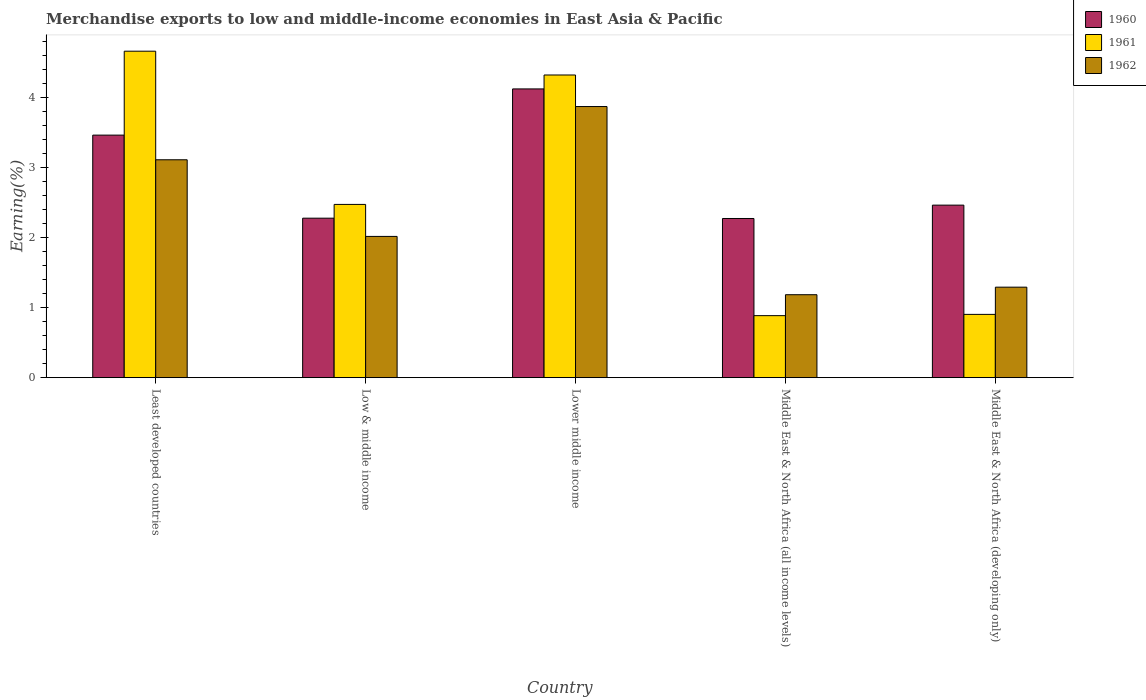How many groups of bars are there?
Your response must be concise. 5. Are the number of bars per tick equal to the number of legend labels?
Offer a terse response. Yes. How many bars are there on the 5th tick from the left?
Provide a short and direct response. 3. What is the label of the 2nd group of bars from the left?
Provide a short and direct response. Low & middle income. In how many cases, is the number of bars for a given country not equal to the number of legend labels?
Provide a succinct answer. 0. What is the percentage of amount earned from merchandise exports in 1962 in Middle East & North Africa (developing only)?
Offer a terse response. 1.29. Across all countries, what is the maximum percentage of amount earned from merchandise exports in 1961?
Provide a short and direct response. 4.66. Across all countries, what is the minimum percentage of amount earned from merchandise exports in 1960?
Keep it short and to the point. 2.27. In which country was the percentage of amount earned from merchandise exports in 1961 maximum?
Offer a terse response. Least developed countries. In which country was the percentage of amount earned from merchandise exports in 1960 minimum?
Make the answer very short. Middle East & North Africa (all income levels). What is the total percentage of amount earned from merchandise exports in 1962 in the graph?
Provide a succinct answer. 11.48. What is the difference between the percentage of amount earned from merchandise exports in 1962 in Low & middle income and that in Middle East & North Africa (developing only)?
Make the answer very short. 0.72. What is the difference between the percentage of amount earned from merchandise exports in 1960 in Middle East & North Africa (all income levels) and the percentage of amount earned from merchandise exports in 1962 in Lower middle income?
Your response must be concise. -1.6. What is the average percentage of amount earned from merchandise exports in 1962 per country?
Make the answer very short. 2.3. What is the difference between the percentage of amount earned from merchandise exports of/in 1961 and percentage of amount earned from merchandise exports of/in 1962 in Least developed countries?
Offer a terse response. 1.55. In how many countries, is the percentage of amount earned from merchandise exports in 1961 greater than 2 %?
Ensure brevity in your answer.  3. What is the ratio of the percentage of amount earned from merchandise exports in 1960 in Middle East & North Africa (all income levels) to that in Middle East & North Africa (developing only)?
Keep it short and to the point. 0.92. Is the percentage of amount earned from merchandise exports in 1962 in Least developed countries less than that in Lower middle income?
Make the answer very short. Yes. What is the difference between the highest and the second highest percentage of amount earned from merchandise exports in 1961?
Your answer should be very brief. -2.19. What is the difference between the highest and the lowest percentage of amount earned from merchandise exports in 1962?
Give a very brief answer. 2.69. In how many countries, is the percentage of amount earned from merchandise exports in 1962 greater than the average percentage of amount earned from merchandise exports in 1962 taken over all countries?
Provide a succinct answer. 2. What does the 1st bar from the right in Lower middle income represents?
Make the answer very short. 1962. Is it the case that in every country, the sum of the percentage of amount earned from merchandise exports in 1962 and percentage of amount earned from merchandise exports in 1961 is greater than the percentage of amount earned from merchandise exports in 1960?
Your response must be concise. No. How many bars are there?
Give a very brief answer. 15. How many countries are there in the graph?
Give a very brief answer. 5. Are the values on the major ticks of Y-axis written in scientific E-notation?
Offer a terse response. No. Does the graph contain any zero values?
Your response must be concise. No. Where does the legend appear in the graph?
Give a very brief answer. Top right. How are the legend labels stacked?
Make the answer very short. Vertical. What is the title of the graph?
Ensure brevity in your answer.  Merchandise exports to low and middle-income economies in East Asia & Pacific. What is the label or title of the X-axis?
Your response must be concise. Country. What is the label or title of the Y-axis?
Give a very brief answer. Earning(%). What is the Earning(%) of 1960 in Least developed countries?
Offer a very short reply. 3.46. What is the Earning(%) in 1961 in Least developed countries?
Offer a terse response. 4.66. What is the Earning(%) in 1962 in Least developed countries?
Your answer should be very brief. 3.11. What is the Earning(%) of 1960 in Low & middle income?
Offer a very short reply. 2.28. What is the Earning(%) of 1961 in Low & middle income?
Keep it short and to the point. 2.47. What is the Earning(%) of 1962 in Low & middle income?
Offer a very short reply. 2.02. What is the Earning(%) of 1960 in Lower middle income?
Provide a short and direct response. 4.12. What is the Earning(%) in 1961 in Lower middle income?
Your answer should be compact. 4.32. What is the Earning(%) of 1962 in Lower middle income?
Your answer should be very brief. 3.87. What is the Earning(%) of 1960 in Middle East & North Africa (all income levels)?
Offer a very short reply. 2.27. What is the Earning(%) of 1961 in Middle East & North Africa (all income levels)?
Give a very brief answer. 0.89. What is the Earning(%) of 1962 in Middle East & North Africa (all income levels)?
Your response must be concise. 1.19. What is the Earning(%) in 1960 in Middle East & North Africa (developing only)?
Your response must be concise. 2.46. What is the Earning(%) in 1961 in Middle East & North Africa (developing only)?
Offer a terse response. 0.9. What is the Earning(%) in 1962 in Middle East & North Africa (developing only)?
Your answer should be very brief. 1.29. Across all countries, what is the maximum Earning(%) of 1960?
Provide a short and direct response. 4.12. Across all countries, what is the maximum Earning(%) in 1961?
Give a very brief answer. 4.66. Across all countries, what is the maximum Earning(%) in 1962?
Make the answer very short. 3.87. Across all countries, what is the minimum Earning(%) of 1960?
Provide a short and direct response. 2.27. Across all countries, what is the minimum Earning(%) in 1961?
Provide a short and direct response. 0.89. Across all countries, what is the minimum Earning(%) in 1962?
Your answer should be compact. 1.19. What is the total Earning(%) of 1960 in the graph?
Keep it short and to the point. 14.61. What is the total Earning(%) of 1961 in the graph?
Keep it short and to the point. 13.25. What is the total Earning(%) of 1962 in the graph?
Make the answer very short. 11.48. What is the difference between the Earning(%) in 1960 in Least developed countries and that in Low & middle income?
Give a very brief answer. 1.19. What is the difference between the Earning(%) in 1961 in Least developed countries and that in Low & middle income?
Ensure brevity in your answer.  2.19. What is the difference between the Earning(%) in 1962 in Least developed countries and that in Low & middle income?
Offer a very short reply. 1.09. What is the difference between the Earning(%) in 1960 in Least developed countries and that in Lower middle income?
Ensure brevity in your answer.  -0.66. What is the difference between the Earning(%) of 1961 in Least developed countries and that in Lower middle income?
Your answer should be compact. 0.34. What is the difference between the Earning(%) of 1962 in Least developed countries and that in Lower middle income?
Provide a short and direct response. -0.76. What is the difference between the Earning(%) of 1960 in Least developed countries and that in Middle East & North Africa (all income levels)?
Offer a terse response. 1.19. What is the difference between the Earning(%) in 1961 in Least developed countries and that in Middle East & North Africa (all income levels)?
Your answer should be compact. 3.78. What is the difference between the Earning(%) in 1962 in Least developed countries and that in Middle East & North Africa (all income levels)?
Make the answer very short. 1.93. What is the difference between the Earning(%) of 1961 in Least developed countries and that in Middle East & North Africa (developing only)?
Provide a short and direct response. 3.76. What is the difference between the Earning(%) of 1962 in Least developed countries and that in Middle East & North Africa (developing only)?
Your answer should be compact. 1.82. What is the difference between the Earning(%) of 1960 in Low & middle income and that in Lower middle income?
Offer a terse response. -1.85. What is the difference between the Earning(%) of 1961 in Low & middle income and that in Lower middle income?
Ensure brevity in your answer.  -1.85. What is the difference between the Earning(%) in 1962 in Low & middle income and that in Lower middle income?
Ensure brevity in your answer.  -1.86. What is the difference between the Earning(%) of 1960 in Low & middle income and that in Middle East & North Africa (all income levels)?
Provide a succinct answer. 0. What is the difference between the Earning(%) in 1961 in Low & middle income and that in Middle East & North Africa (all income levels)?
Ensure brevity in your answer.  1.59. What is the difference between the Earning(%) of 1962 in Low & middle income and that in Middle East & North Africa (all income levels)?
Ensure brevity in your answer.  0.83. What is the difference between the Earning(%) of 1960 in Low & middle income and that in Middle East & North Africa (developing only)?
Your answer should be compact. -0.19. What is the difference between the Earning(%) of 1961 in Low & middle income and that in Middle East & North Africa (developing only)?
Offer a very short reply. 1.57. What is the difference between the Earning(%) of 1962 in Low & middle income and that in Middle East & North Africa (developing only)?
Offer a terse response. 0.72. What is the difference between the Earning(%) in 1960 in Lower middle income and that in Middle East & North Africa (all income levels)?
Make the answer very short. 1.85. What is the difference between the Earning(%) in 1961 in Lower middle income and that in Middle East & North Africa (all income levels)?
Ensure brevity in your answer.  3.44. What is the difference between the Earning(%) in 1962 in Lower middle income and that in Middle East & North Africa (all income levels)?
Your response must be concise. 2.69. What is the difference between the Earning(%) in 1960 in Lower middle income and that in Middle East & North Africa (developing only)?
Keep it short and to the point. 1.66. What is the difference between the Earning(%) in 1961 in Lower middle income and that in Middle East & North Africa (developing only)?
Your answer should be compact. 3.42. What is the difference between the Earning(%) in 1962 in Lower middle income and that in Middle East & North Africa (developing only)?
Your answer should be very brief. 2.58. What is the difference between the Earning(%) in 1960 in Middle East & North Africa (all income levels) and that in Middle East & North Africa (developing only)?
Provide a short and direct response. -0.19. What is the difference between the Earning(%) of 1961 in Middle East & North Africa (all income levels) and that in Middle East & North Africa (developing only)?
Your answer should be compact. -0.02. What is the difference between the Earning(%) in 1962 in Middle East & North Africa (all income levels) and that in Middle East & North Africa (developing only)?
Ensure brevity in your answer.  -0.11. What is the difference between the Earning(%) of 1960 in Least developed countries and the Earning(%) of 1962 in Low & middle income?
Your answer should be compact. 1.45. What is the difference between the Earning(%) in 1961 in Least developed countries and the Earning(%) in 1962 in Low & middle income?
Your answer should be compact. 2.65. What is the difference between the Earning(%) of 1960 in Least developed countries and the Earning(%) of 1961 in Lower middle income?
Your answer should be compact. -0.86. What is the difference between the Earning(%) in 1960 in Least developed countries and the Earning(%) in 1962 in Lower middle income?
Your answer should be very brief. -0.41. What is the difference between the Earning(%) of 1961 in Least developed countries and the Earning(%) of 1962 in Lower middle income?
Ensure brevity in your answer.  0.79. What is the difference between the Earning(%) of 1960 in Least developed countries and the Earning(%) of 1961 in Middle East & North Africa (all income levels)?
Your answer should be very brief. 2.58. What is the difference between the Earning(%) in 1960 in Least developed countries and the Earning(%) in 1962 in Middle East & North Africa (all income levels)?
Give a very brief answer. 2.28. What is the difference between the Earning(%) in 1961 in Least developed countries and the Earning(%) in 1962 in Middle East & North Africa (all income levels)?
Keep it short and to the point. 3.48. What is the difference between the Earning(%) of 1960 in Least developed countries and the Earning(%) of 1961 in Middle East & North Africa (developing only)?
Offer a terse response. 2.56. What is the difference between the Earning(%) of 1960 in Least developed countries and the Earning(%) of 1962 in Middle East & North Africa (developing only)?
Your answer should be compact. 2.17. What is the difference between the Earning(%) of 1961 in Least developed countries and the Earning(%) of 1962 in Middle East & North Africa (developing only)?
Provide a short and direct response. 3.37. What is the difference between the Earning(%) in 1960 in Low & middle income and the Earning(%) in 1961 in Lower middle income?
Your answer should be very brief. -2.05. What is the difference between the Earning(%) in 1960 in Low & middle income and the Earning(%) in 1962 in Lower middle income?
Make the answer very short. -1.59. What is the difference between the Earning(%) of 1961 in Low & middle income and the Earning(%) of 1962 in Lower middle income?
Your answer should be compact. -1.4. What is the difference between the Earning(%) of 1960 in Low & middle income and the Earning(%) of 1961 in Middle East & North Africa (all income levels)?
Provide a short and direct response. 1.39. What is the difference between the Earning(%) of 1960 in Low & middle income and the Earning(%) of 1962 in Middle East & North Africa (all income levels)?
Keep it short and to the point. 1.09. What is the difference between the Earning(%) in 1961 in Low & middle income and the Earning(%) in 1962 in Middle East & North Africa (all income levels)?
Provide a succinct answer. 1.29. What is the difference between the Earning(%) in 1960 in Low & middle income and the Earning(%) in 1961 in Middle East & North Africa (developing only)?
Your answer should be very brief. 1.37. What is the difference between the Earning(%) in 1960 in Low & middle income and the Earning(%) in 1962 in Middle East & North Africa (developing only)?
Give a very brief answer. 0.99. What is the difference between the Earning(%) of 1961 in Low & middle income and the Earning(%) of 1962 in Middle East & North Africa (developing only)?
Your response must be concise. 1.18. What is the difference between the Earning(%) of 1960 in Lower middle income and the Earning(%) of 1961 in Middle East & North Africa (all income levels)?
Your answer should be very brief. 3.24. What is the difference between the Earning(%) of 1960 in Lower middle income and the Earning(%) of 1962 in Middle East & North Africa (all income levels)?
Offer a terse response. 2.94. What is the difference between the Earning(%) in 1961 in Lower middle income and the Earning(%) in 1962 in Middle East & North Africa (all income levels)?
Your response must be concise. 3.14. What is the difference between the Earning(%) in 1960 in Lower middle income and the Earning(%) in 1961 in Middle East & North Africa (developing only)?
Give a very brief answer. 3.22. What is the difference between the Earning(%) in 1960 in Lower middle income and the Earning(%) in 1962 in Middle East & North Africa (developing only)?
Offer a terse response. 2.83. What is the difference between the Earning(%) of 1961 in Lower middle income and the Earning(%) of 1962 in Middle East & North Africa (developing only)?
Offer a very short reply. 3.03. What is the difference between the Earning(%) in 1960 in Middle East & North Africa (all income levels) and the Earning(%) in 1961 in Middle East & North Africa (developing only)?
Your answer should be very brief. 1.37. What is the difference between the Earning(%) in 1960 in Middle East & North Africa (all income levels) and the Earning(%) in 1962 in Middle East & North Africa (developing only)?
Keep it short and to the point. 0.98. What is the difference between the Earning(%) in 1961 in Middle East & North Africa (all income levels) and the Earning(%) in 1962 in Middle East & North Africa (developing only)?
Your response must be concise. -0.41. What is the average Earning(%) in 1960 per country?
Your response must be concise. 2.92. What is the average Earning(%) in 1961 per country?
Provide a succinct answer. 2.65. What is the average Earning(%) in 1962 per country?
Your answer should be very brief. 2.3. What is the difference between the Earning(%) of 1960 and Earning(%) of 1961 in Least developed countries?
Ensure brevity in your answer.  -1.2. What is the difference between the Earning(%) in 1960 and Earning(%) in 1962 in Least developed countries?
Provide a short and direct response. 0.35. What is the difference between the Earning(%) in 1961 and Earning(%) in 1962 in Least developed countries?
Your answer should be compact. 1.55. What is the difference between the Earning(%) of 1960 and Earning(%) of 1961 in Low & middle income?
Offer a terse response. -0.2. What is the difference between the Earning(%) in 1960 and Earning(%) in 1962 in Low & middle income?
Your response must be concise. 0.26. What is the difference between the Earning(%) in 1961 and Earning(%) in 1962 in Low & middle income?
Your answer should be compact. 0.46. What is the difference between the Earning(%) in 1960 and Earning(%) in 1961 in Lower middle income?
Provide a succinct answer. -0.2. What is the difference between the Earning(%) in 1960 and Earning(%) in 1962 in Lower middle income?
Your answer should be compact. 0.25. What is the difference between the Earning(%) of 1961 and Earning(%) of 1962 in Lower middle income?
Offer a terse response. 0.45. What is the difference between the Earning(%) of 1960 and Earning(%) of 1961 in Middle East & North Africa (all income levels)?
Give a very brief answer. 1.39. What is the difference between the Earning(%) of 1960 and Earning(%) of 1962 in Middle East & North Africa (all income levels)?
Your response must be concise. 1.09. What is the difference between the Earning(%) of 1961 and Earning(%) of 1962 in Middle East & North Africa (all income levels)?
Keep it short and to the point. -0.3. What is the difference between the Earning(%) of 1960 and Earning(%) of 1961 in Middle East & North Africa (developing only)?
Offer a terse response. 1.56. What is the difference between the Earning(%) in 1960 and Earning(%) in 1962 in Middle East & North Africa (developing only)?
Ensure brevity in your answer.  1.17. What is the difference between the Earning(%) of 1961 and Earning(%) of 1962 in Middle East & North Africa (developing only)?
Offer a terse response. -0.39. What is the ratio of the Earning(%) in 1960 in Least developed countries to that in Low & middle income?
Keep it short and to the point. 1.52. What is the ratio of the Earning(%) of 1961 in Least developed countries to that in Low & middle income?
Your response must be concise. 1.88. What is the ratio of the Earning(%) of 1962 in Least developed countries to that in Low & middle income?
Offer a terse response. 1.54. What is the ratio of the Earning(%) of 1960 in Least developed countries to that in Lower middle income?
Your response must be concise. 0.84. What is the ratio of the Earning(%) in 1961 in Least developed countries to that in Lower middle income?
Your answer should be very brief. 1.08. What is the ratio of the Earning(%) in 1962 in Least developed countries to that in Lower middle income?
Ensure brevity in your answer.  0.8. What is the ratio of the Earning(%) of 1960 in Least developed countries to that in Middle East & North Africa (all income levels)?
Give a very brief answer. 1.52. What is the ratio of the Earning(%) in 1961 in Least developed countries to that in Middle East & North Africa (all income levels)?
Make the answer very short. 5.26. What is the ratio of the Earning(%) of 1962 in Least developed countries to that in Middle East & North Africa (all income levels)?
Offer a terse response. 2.63. What is the ratio of the Earning(%) in 1960 in Least developed countries to that in Middle East & North Africa (developing only)?
Offer a very short reply. 1.41. What is the ratio of the Earning(%) of 1961 in Least developed countries to that in Middle East & North Africa (developing only)?
Offer a terse response. 5.16. What is the ratio of the Earning(%) of 1962 in Least developed countries to that in Middle East & North Africa (developing only)?
Keep it short and to the point. 2.41. What is the ratio of the Earning(%) of 1960 in Low & middle income to that in Lower middle income?
Provide a succinct answer. 0.55. What is the ratio of the Earning(%) of 1961 in Low & middle income to that in Lower middle income?
Provide a short and direct response. 0.57. What is the ratio of the Earning(%) in 1962 in Low & middle income to that in Lower middle income?
Give a very brief answer. 0.52. What is the ratio of the Earning(%) in 1960 in Low & middle income to that in Middle East & North Africa (all income levels)?
Offer a very short reply. 1. What is the ratio of the Earning(%) in 1961 in Low & middle income to that in Middle East & North Africa (all income levels)?
Your response must be concise. 2.79. What is the ratio of the Earning(%) of 1962 in Low & middle income to that in Middle East & North Africa (all income levels)?
Ensure brevity in your answer.  1.7. What is the ratio of the Earning(%) in 1960 in Low & middle income to that in Middle East & North Africa (developing only)?
Ensure brevity in your answer.  0.92. What is the ratio of the Earning(%) of 1961 in Low & middle income to that in Middle East & North Africa (developing only)?
Your answer should be very brief. 2.74. What is the ratio of the Earning(%) in 1962 in Low & middle income to that in Middle East & North Africa (developing only)?
Ensure brevity in your answer.  1.56. What is the ratio of the Earning(%) in 1960 in Lower middle income to that in Middle East & North Africa (all income levels)?
Your answer should be very brief. 1.81. What is the ratio of the Earning(%) in 1961 in Lower middle income to that in Middle East & North Africa (all income levels)?
Your response must be concise. 4.88. What is the ratio of the Earning(%) in 1962 in Lower middle income to that in Middle East & North Africa (all income levels)?
Keep it short and to the point. 3.27. What is the ratio of the Earning(%) in 1960 in Lower middle income to that in Middle East & North Africa (developing only)?
Give a very brief answer. 1.67. What is the ratio of the Earning(%) of 1961 in Lower middle income to that in Middle East & North Africa (developing only)?
Your response must be concise. 4.78. What is the ratio of the Earning(%) of 1962 in Lower middle income to that in Middle East & North Africa (developing only)?
Provide a short and direct response. 3. What is the ratio of the Earning(%) of 1960 in Middle East & North Africa (all income levels) to that in Middle East & North Africa (developing only)?
Provide a short and direct response. 0.92. What is the ratio of the Earning(%) in 1961 in Middle East & North Africa (all income levels) to that in Middle East & North Africa (developing only)?
Offer a terse response. 0.98. What is the ratio of the Earning(%) in 1962 in Middle East & North Africa (all income levels) to that in Middle East & North Africa (developing only)?
Give a very brief answer. 0.92. What is the difference between the highest and the second highest Earning(%) of 1960?
Offer a terse response. 0.66. What is the difference between the highest and the second highest Earning(%) of 1961?
Your response must be concise. 0.34. What is the difference between the highest and the second highest Earning(%) of 1962?
Ensure brevity in your answer.  0.76. What is the difference between the highest and the lowest Earning(%) in 1960?
Offer a very short reply. 1.85. What is the difference between the highest and the lowest Earning(%) in 1961?
Provide a short and direct response. 3.78. What is the difference between the highest and the lowest Earning(%) of 1962?
Provide a succinct answer. 2.69. 